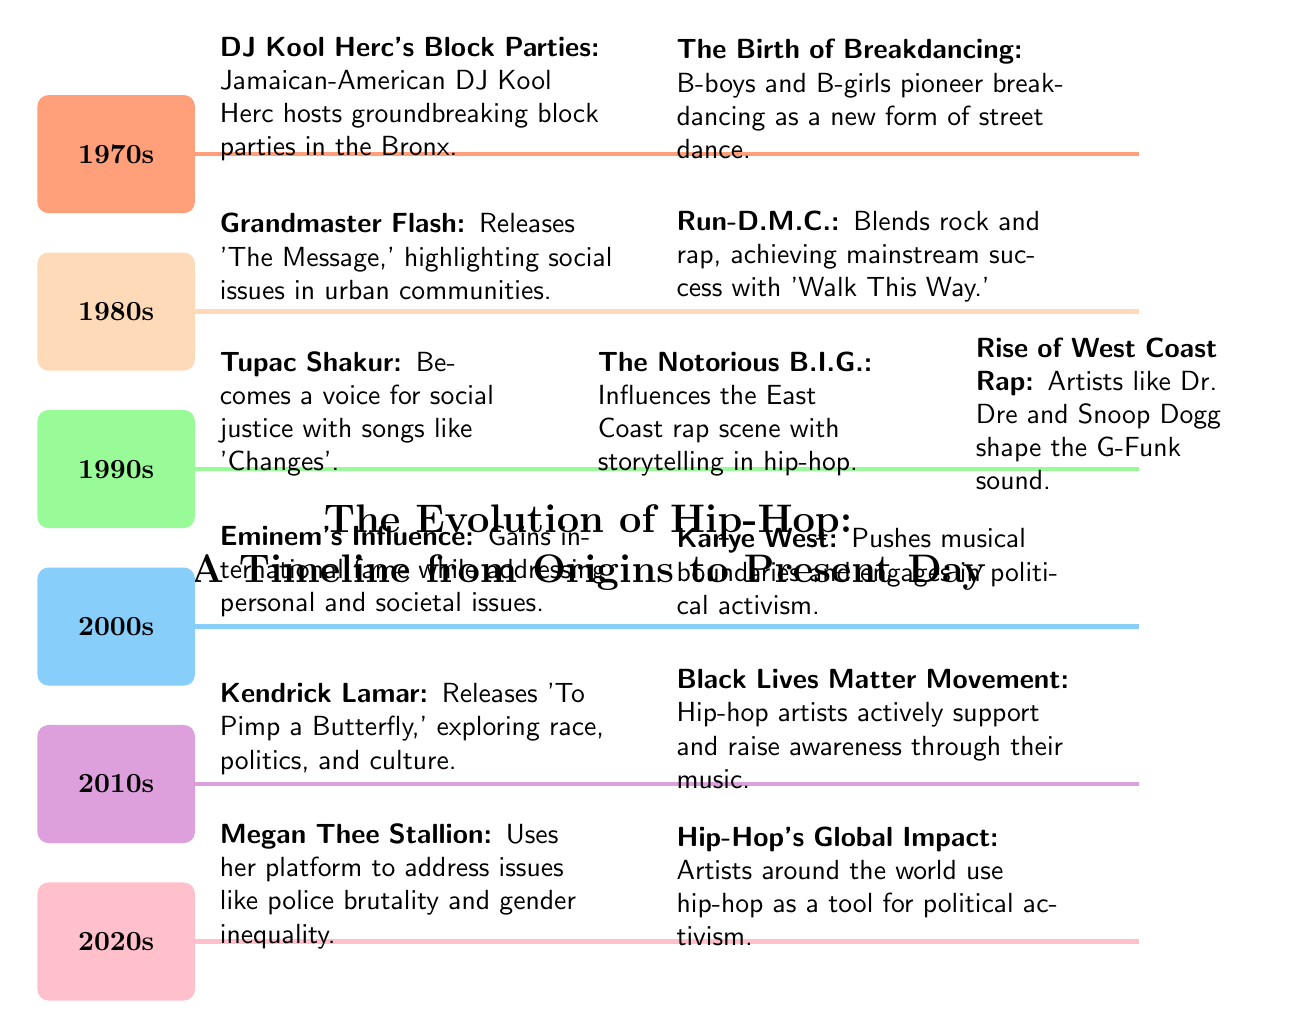What decade did DJ Kool Herc host his groundbreaking block parties? According to the diagram, DJ Kool Herc's block parties occurred in the 1970s, which is specified in the timeline on the left side of the diagram.
Answer: 1970s Which hip-hop artist highlighted social issues in the 1980s? The diagram indicates that Grandmaster Flash released 'The Message' in the 1980s, which emphasized social issues in urban communities.
Answer: Grandmaster Flash What is the significance of Kendrick Lamar's album 'To Pimp a Butterfly'? The diagram states that Kendrick Lamar's album explores themes of race, politics, and culture, indicating its significance in addressing important societal issues through hip-hop.
Answer: Exploring race, politics, and culture How many decades are represented in the diagram? The diagram shows six distinct decades, from the 1970s to the 2020s, each marked with specific events related to hip-hop's evolution.
Answer: 6 What movement did hip-hop artists actively support in the 2010s? The 2010s section of the diagram highlights the Black Lives Matter Movement as a significant cause that hip-hop artists supported and raised awareness about through their music.
Answer: Black Lives Matter Movement Which artist blended rock and rap in the 1980s? According to the timeline, Run-D.M.C. is credited with blending rock and rap, achieving mainstream success during the 1980s.
Answer: Run-D.M.C What global impact does hip-hop have in the 2020s, according to the diagram? The diagram indicates that in the 2020s, hip-hop artists around the world are using hip-hop as a tool for political activism, showcasing its global influence.
Answer: Artists use hip-hop as a tool for political activism Which artist is known for addressing personal and societal issues? The diagram notes that Eminem gained international fame while addressing both personal and societal issues in his music.
Answer: Eminem What role does Megan Thee Stallion play in addressing social issues? The diagram specifies that Megan Thee Stallion uses her platform to address issues like police brutality and gender inequality, highlighting her contribution to social activism through music.
Answer: Addressing police brutality and gender inequality 